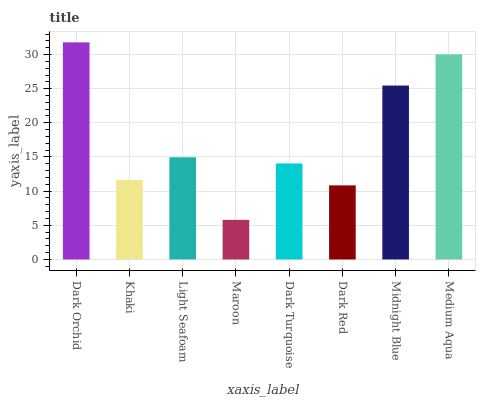Is Maroon the minimum?
Answer yes or no. Yes. Is Dark Orchid the maximum?
Answer yes or no. Yes. Is Khaki the minimum?
Answer yes or no. No. Is Khaki the maximum?
Answer yes or no. No. Is Dark Orchid greater than Khaki?
Answer yes or no. Yes. Is Khaki less than Dark Orchid?
Answer yes or no. Yes. Is Khaki greater than Dark Orchid?
Answer yes or no. No. Is Dark Orchid less than Khaki?
Answer yes or no. No. Is Light Seafoam the high median?
Answer yes or no. Yes. Is Dark Turquoise the low median?
Answer yes or no. Yes. Is Dark Turquoise the high median?
Answer yes or no. No. Is Midnight Blue the low median?
Answer yes or no. No. 